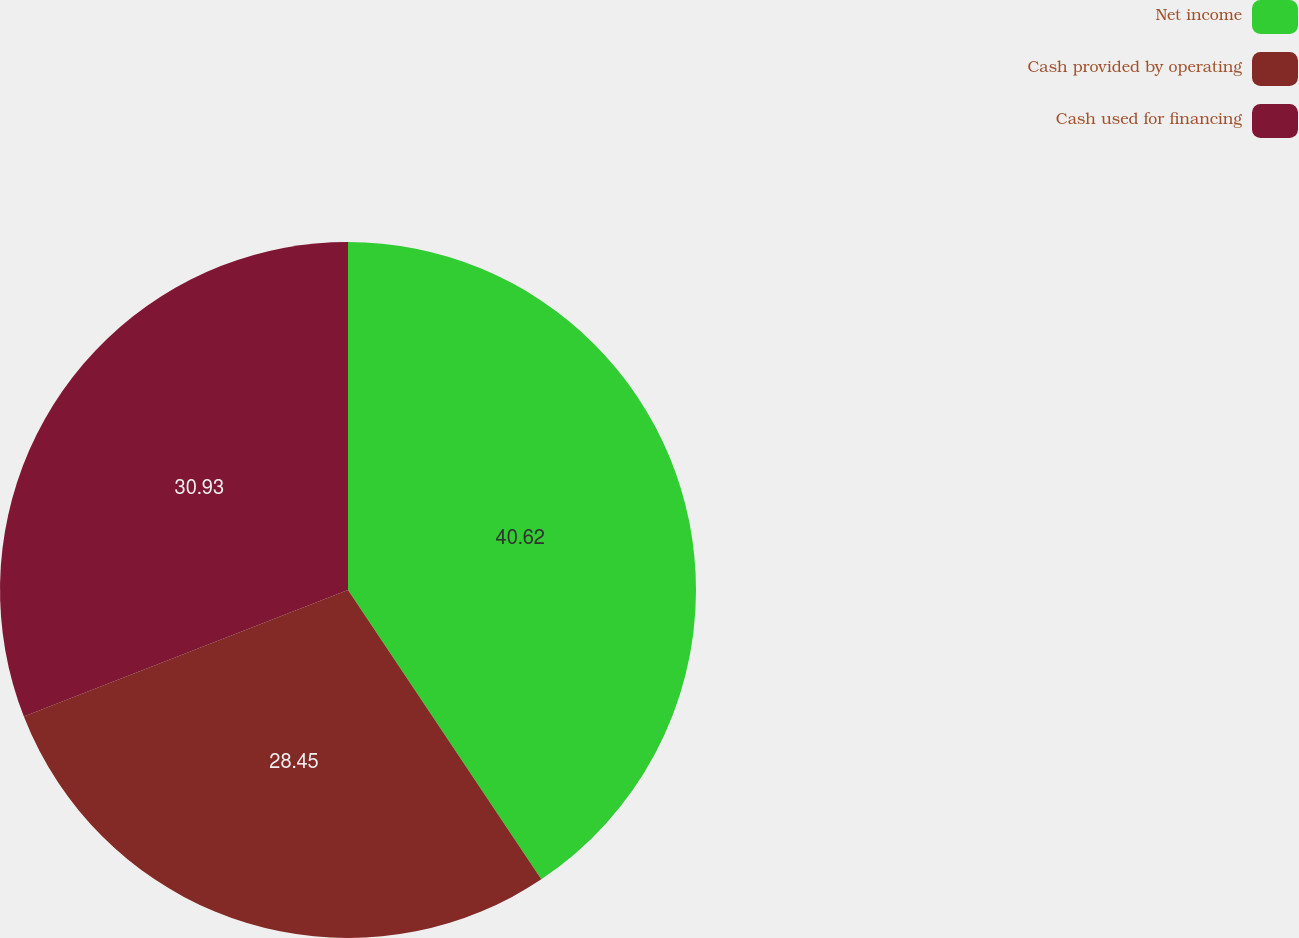Convert chart to OTSL. <chart><loc_0><loc_0><loc_500><loc_500><pie_chart><fcel>Net income<fcel>Cash provided by operating<fcel>Cash used for financing<nl><fcel>40.63%<fcel>28.45%<fcel>30.93%<nl></chart> 